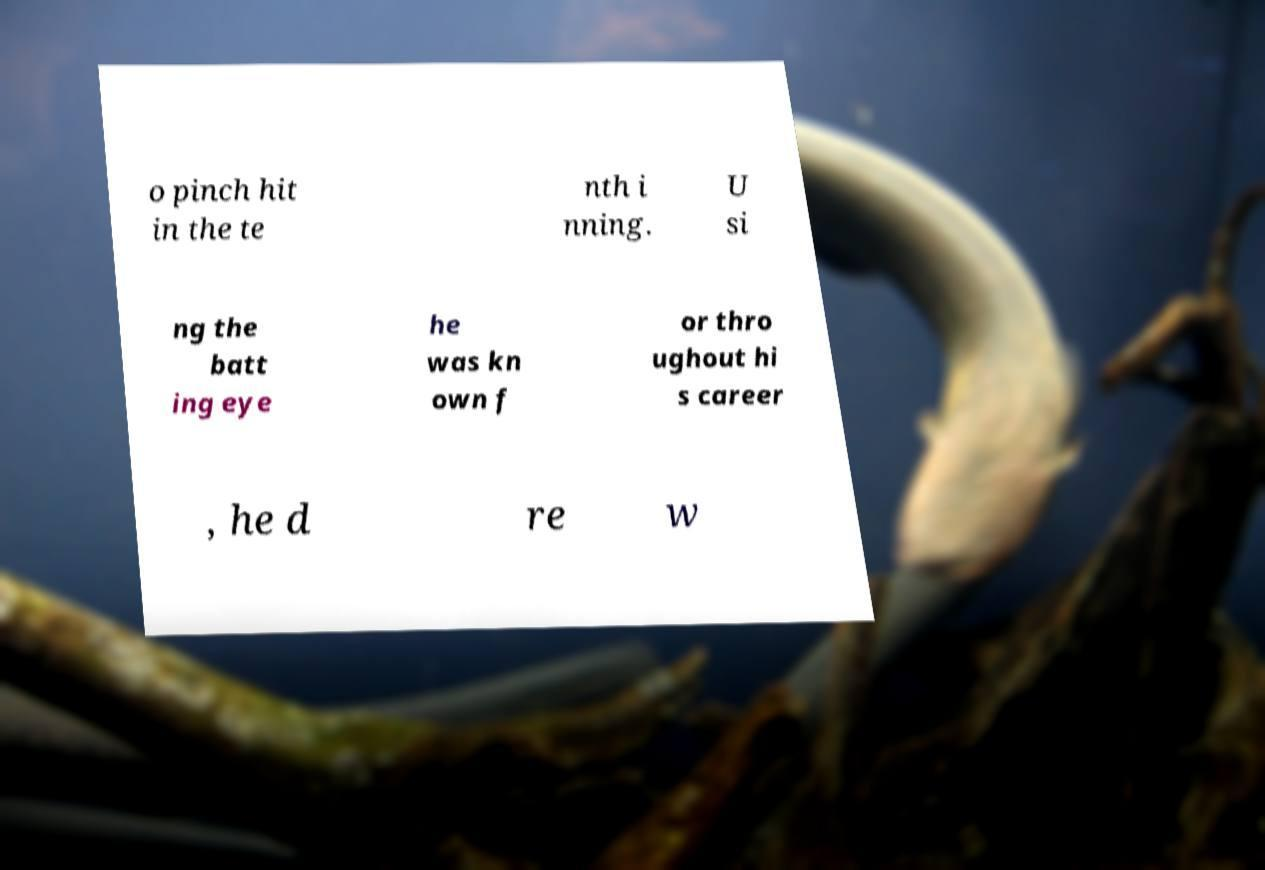There's text embedded in this image that I need extracted. Can you transcribe it verbatim? o pinch hit in the te nth i nning. U si ng the batt ing eye he was kn own f or thro ughout hi s career , he d re w 